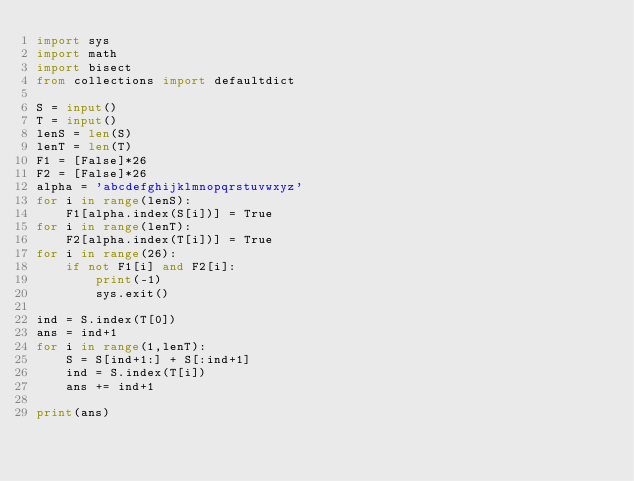<code> <loc_0><loc_0><loc_500><loc_500><_Python_>import sys
import math
import bisect
from collections import defaultdict

S = input()
T = input()
lenS = len(S)
lenT = len(T)
F1 = [False]*26
F2 = [False]*26
alpha = 'abcdefghijklmnopqrstuvwxyz'
for i in range(lenS):
    F1[alpha.index(S[i])] = True
for i in range(lenT):
    F2[alpha.index(T[i])] = True
for i in range(26):
    if not F1[i] and F2[i]:
        print(-1)
        sys.exit()

ind = S.index(T[0])
ans = ind+1
for i in range(1,lenT):
    S = S[ind+1:] + S[:ind+1]
    ind = S.index(T[i])
    ans += ind+1

print(ans)</code> 